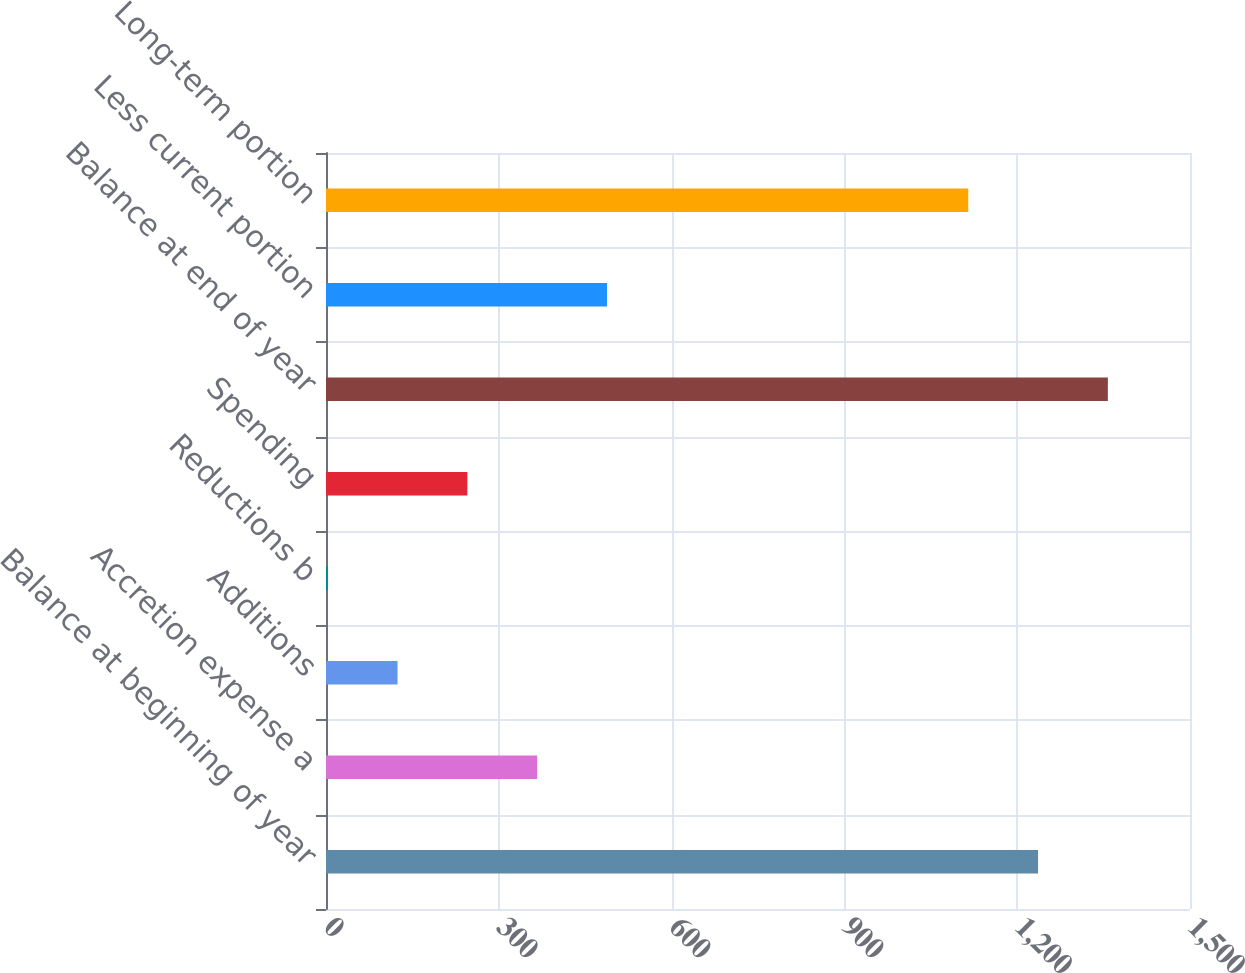Convert chart to OTSL. <chart><loc_0><loc_0><loc_500><loc_500><bar_chart><fcel>Balance at beginning of year<fcel>Accretion expense a<fcel>Additions<fcel>Reductions b<fcel>Spending<fcel>Balance at end of year<fcel>Less current portion<fcel>Long-term portion<nl><fcel>1236.2<fcel>366.6<fcel>124.2<fcel>3<fcel>245.4<fcel>1357.4<fcel>487.8<fcel>1115<nl></chart> 